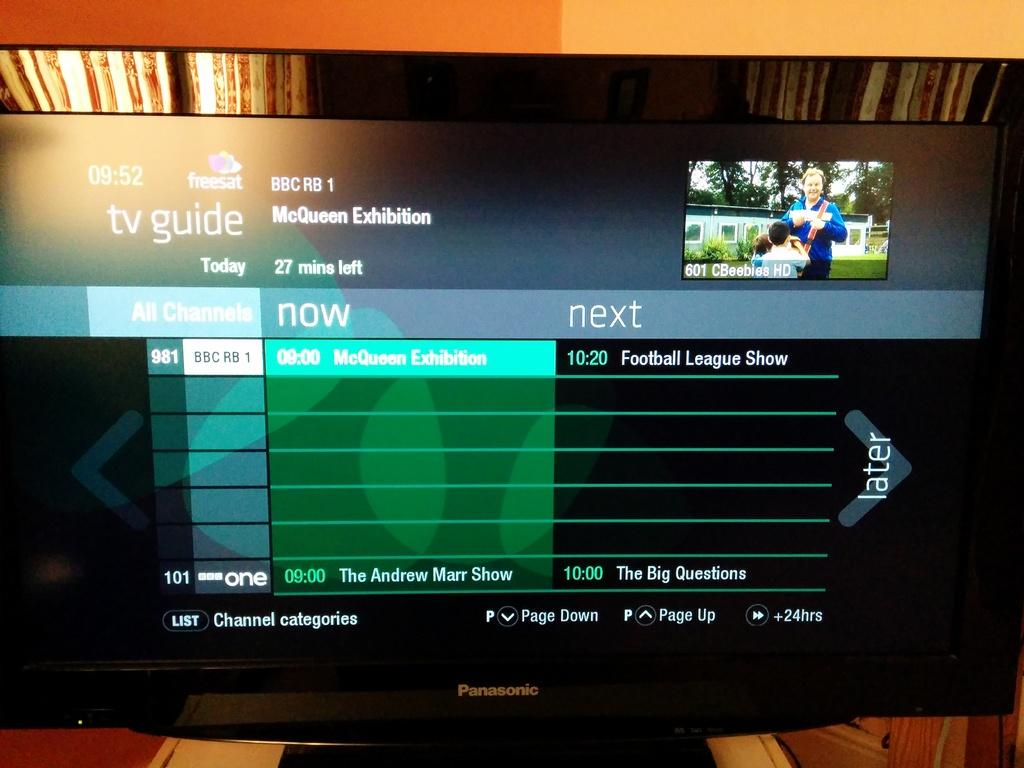<image>
Share a concise interpretation of the image provided. the tv guide and what is on now and next 